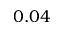<formula> <loc_0><loc_0><loc_500><loc_500>0 . 0 4</formula> 